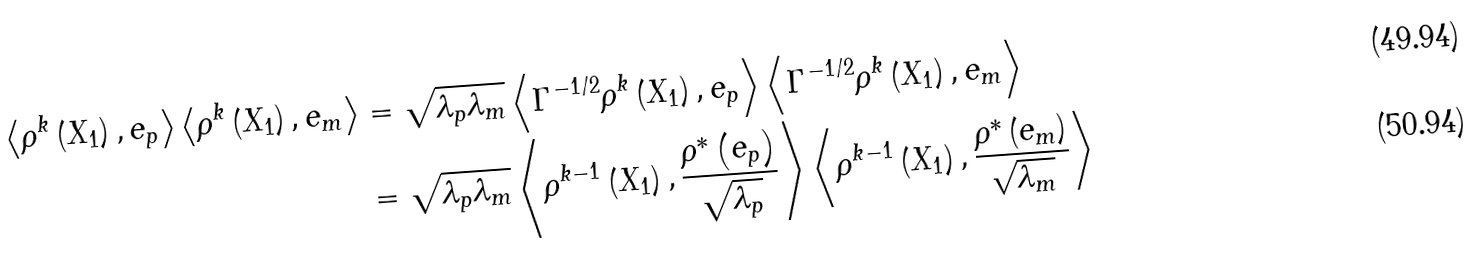<formula> <loc_0><loc_0><loc_500><loc_500>\left \langle \rho ^ { k } \left ( X _ { 1 } \right ) , e _ { p } \right \rangle \left \langle \rho ^ { k } \left ( X _ { 1 } \right ) , e _ { m } \right \rangle & = \sqrt { \lambda _ { p } \lambda _ { m } } \left \langle \Gamma ^ { - 1 / 2 } \rho ^ { k } \left ( X _ { 1 } \right ) , e _ { p } \right \rangle \left \langle \Gamma ^ { - 1 / 2 } \rho ^ { k } \left ( X _ { 1 } \right ) , e _ { m } \right \rangle \\ & = \sqrt { \lambda _ { p } \lambda _ { m } } \left \langle \rho ^ { k - 1 } \left ( X _ { 1 } \right ) , \frac { \rho ^ { \ast } \left ( e _ { p } \right ) } { \sqrt { \lambda _ { p } } } \right \rangle \left \langle \rho ^ { k - 1 } \left ( X _ { 1 } \right ) , \frac { \rho ^ { \ast } \left ( e _ { m } \right ) } { \sqrt { \lambda _ { m } } } \right \rangle</formula> 